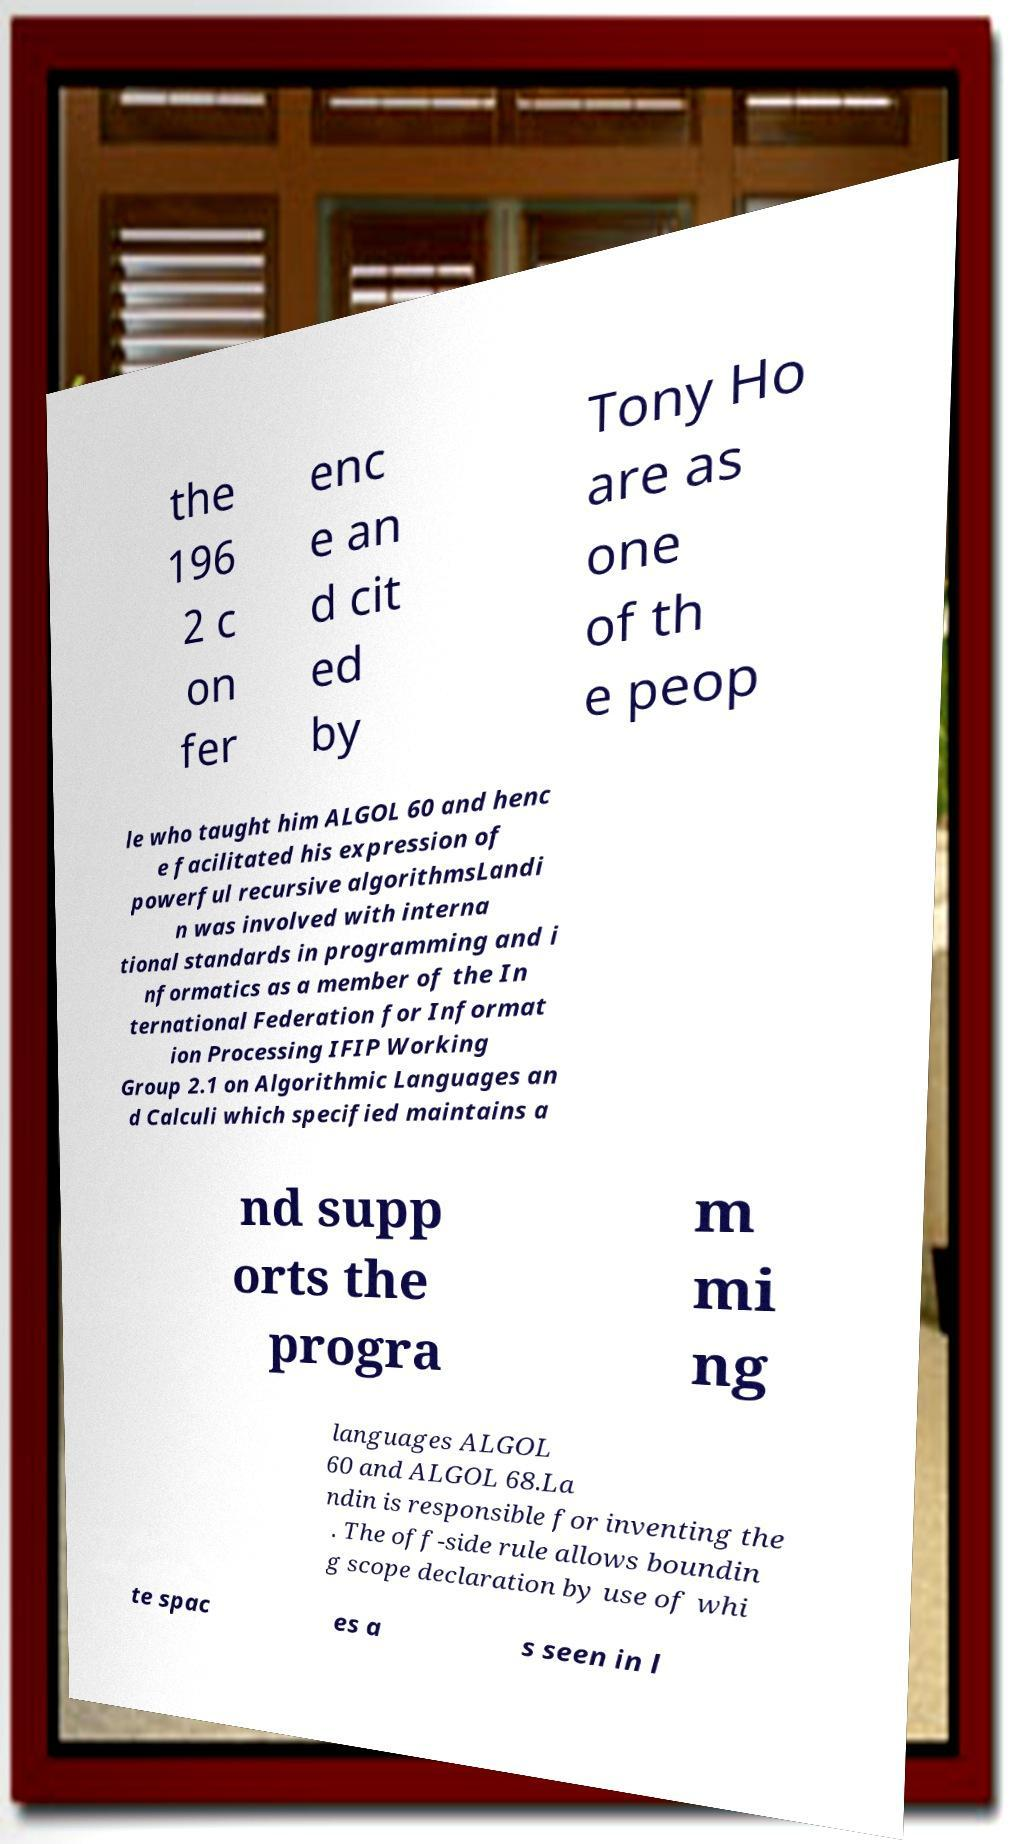Can you accurately transcribe the text from the provided image for me? the 196 2 c on fer enc e an d cit ed by Tony Ho are as one of th e peop le who taught him ALGOL 60 and henc e facilitated his expression of powerful recursive algorithmsLandi n was involved with interna tional standards in programming and i nformatics as a member of the In ternational Federation for Informat ion Processing IFIP Working Group 2.1 on Algorithmic Languages an d Calculi which specified maintains a nd supp orts the progra m mi ng languages ALGOL 60 and ALGOL 68.La ndin is responsible for inventing the . The off-side rule allows boundin g scope declaration by use of whi te spac es a s seen in l 